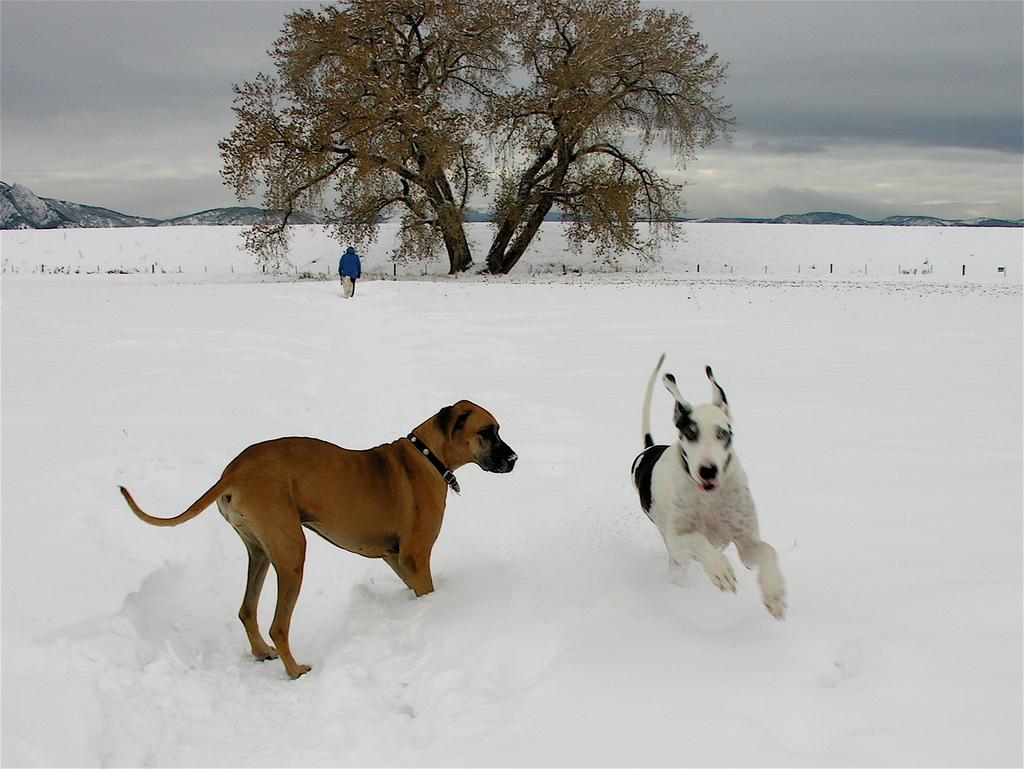Please provide a concise description of this image. In this image there are two dogs which are playing in the snow. In the background there is a tree. Beside the tree there is a person standing in the snow. At the top there is the sky. In the background there are mountains. 